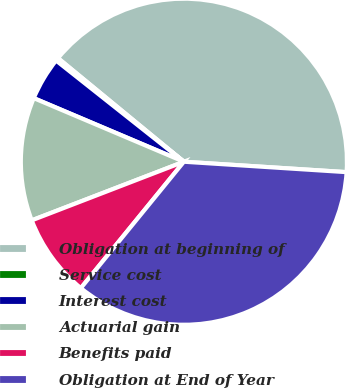<chart> <loc_0><loc_0><loc_500><loc_500><pie_chart><fcel>Obligation at beginning of<fcel>Service cost<fcel>Interest cost<fcel>Actuarial gain<fcel>Benefits paid<fcel>Obligation at End of Year<nl><fcel>40.06%<fcel>0.3%<fcel>4.28%<fcel>12.23%<fcel>8.26%<fcel>34.87%<nl></chart> 